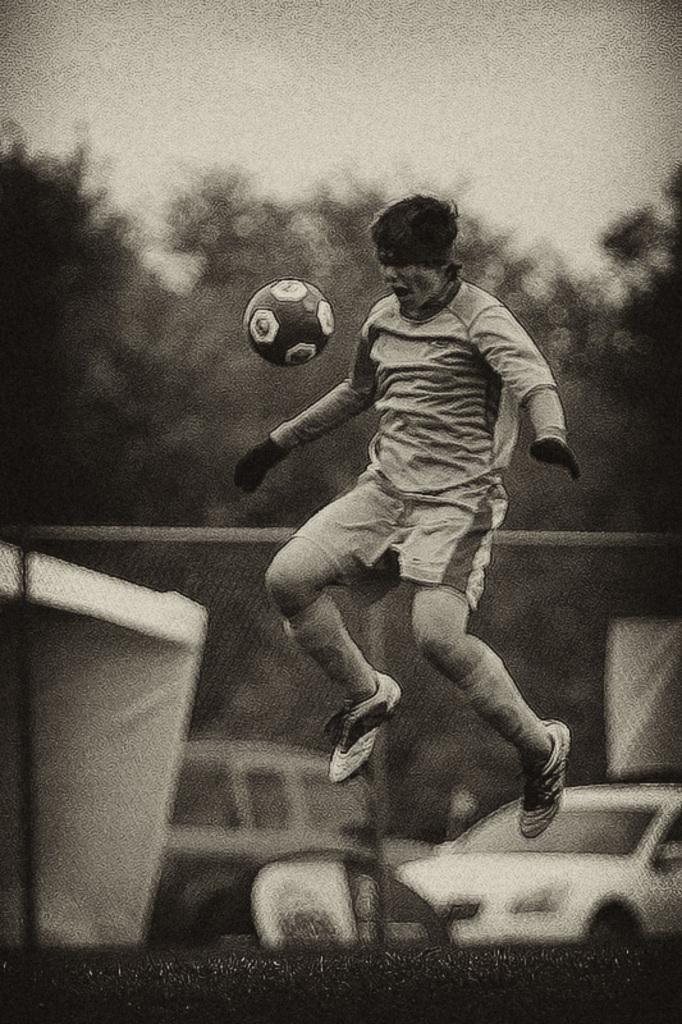Who is the main subject in the image? There is a man in the image. What is the man doing in the image? The man is jumping in the image. What can be seen flying in the air in front of the man? There is a ball flying in the air in front of the man. What is the appearance of the background in the image? The background of the man is blurred. What type of government is depicted in the image? There is no depiction of a government in the image; it features a man jumping with a ball flying in the air. How many fingers is the man holding up in the image? There is no indication of the man holding up any fingers in the image. 